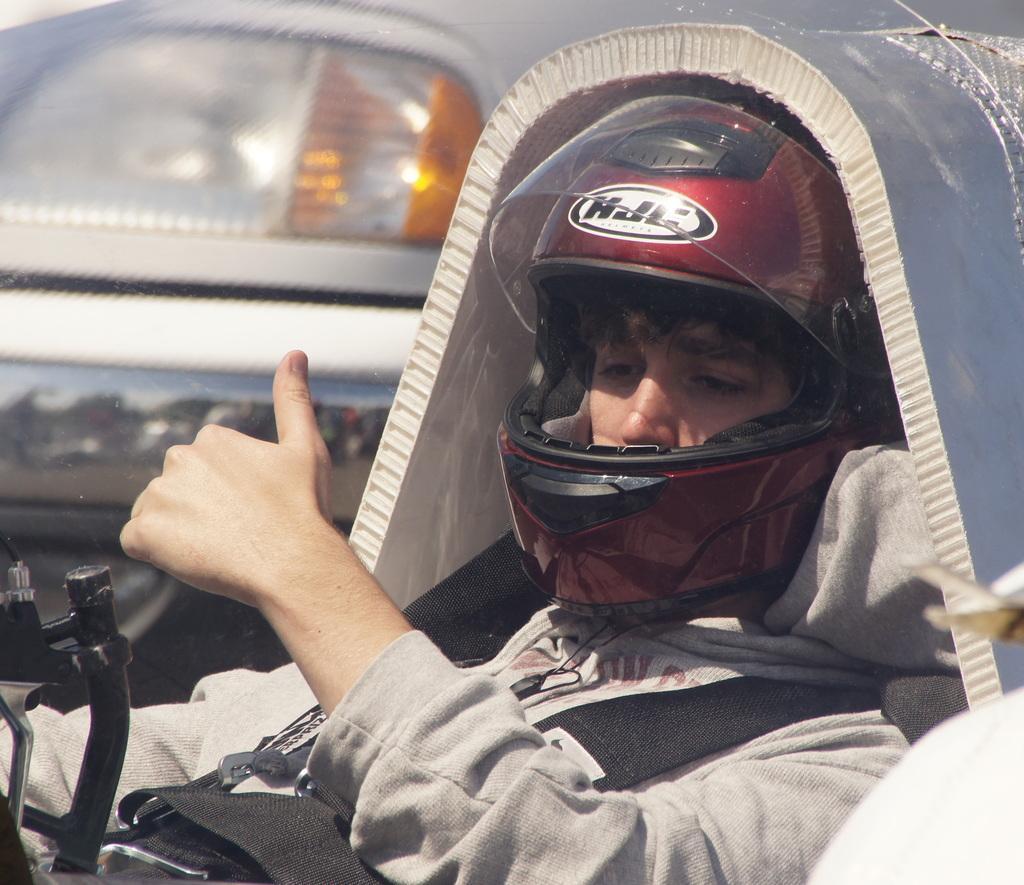Could you give a brief overview of what you see in this image? In this image we can see a person, helmet and other objects. In the background of the image there is a vehicle and other objects. On the right side of the image there is an object. 